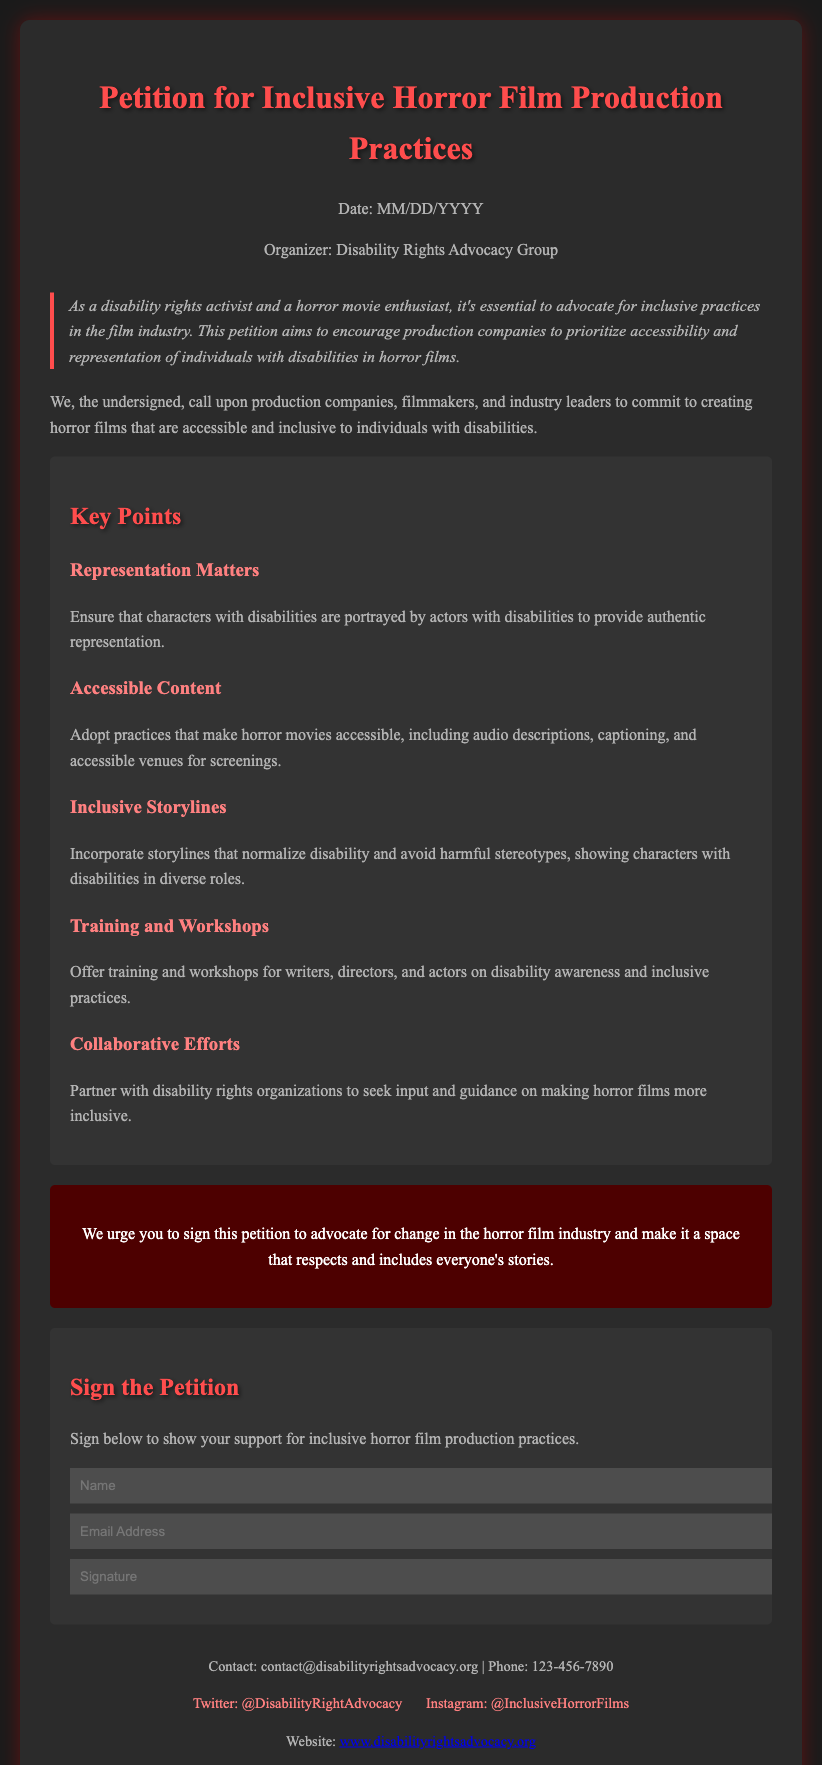What is the title of the petition? The title of the petition is stated at the top of the document.
Answer: Petition for Inclusive Horror Film Production Practices Who organized the petition? The document specifies the organizer of the petition.
Answer: Disability Rights Advocacy Group What is the date format used in the document? The date is mentioned in a placeholder format within the document.
Answer: MM/DD/YYYY What kind of content does the petition advocate for? The petition aims to encourage specific practices related to film production.
Answer: Accessibility and representation Name one key point mentioned in the petition. The document lists several key points advocating for inclusivity.
Answer: Representation Matters What should actors do according to the representation matter? This point specifies the expected behavior of actors regarding their roles in the film.
Answer: Portrayed by actors with disabilities What is provided for signing the petition? The section indicates what information is required from supporters.
Answer: Name, Email Address, Signature What kind of training is suggested for filmmakers? The petition suggests a specific type of training to promote inclusivity.
Answer: Disability awareness How can supporters contact the organizer? The footer section provides contact details for inquiries.
Answer: contact@disabilityrightsadvocacy.org 